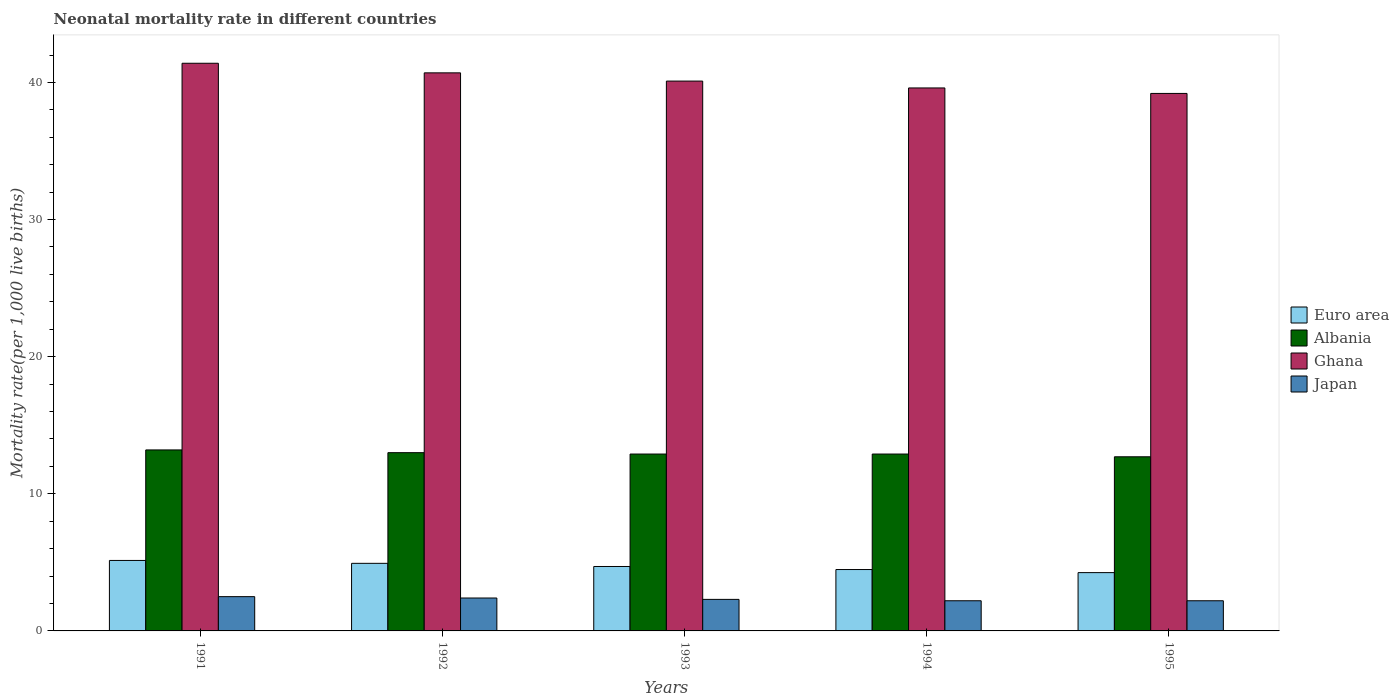How many different coloured bars are there?
Make the answer very short. 4. Are the number of bars per tick equal to the number of legend labels?
Your answer should be very brief. Yes. Are the number of bars on each tick of the X-axis equal?
Offer a terse response. Yes. How many bars are there on the 1st tick from the right?
Provide a short and direct response. 4. What is the neonatal mortality rate in Euro area in 1993?
Provide a short and direct response. 4.7. Across all years, what is the maximum neonatal mortality rate in Ghana?
Give a very brief answer. 41.4. Across all years, what is the minimum neonatal mortality rate in Euro area?
Your answer should be very brief. 4.25. In which year was the neonatal mortality rate in Albania maximum?
Give a very brief answer. 1991. In which year was the neonatal mortality rate in Albania minimum?
Your answer should be compact. 1995. What is the total neonatal mortality rate in Japan in the graph?
Your answer should be compact. 11.6. What is the difference between the neonatal mortality rate in Ghana in 1993 and that in 1994?
Offer a very short reply. 0.5. What is the difference between the neonatal mortality rate in Euro area in 1993 and the neonatal mortality rate in Albania in 1995?
Your answer should be very brief. -8. What is the average neonatal mortality rate in Japan per year?
Give a very brief answer. 2.32. In the year 1995, what is the difference between the neonatal mortality rate in Japan and neonatal mortality rate in Euro area?
Your answer should be very brief. -2.05. In how many years, is the neonatal mortality rate in Ghana greater than 6?
Keep it short and to the point. 5. What is the ratio of the neonatal mortality rate in Ghana in 1993 to that in 1994?
Give a very brief answer. 1.01. Is the difference between the neonatal mortality rate in Japan in 1991 and 1992 greater than the difference between the neonatal mortality rate in Euro area in 1991 and 1992?
Make the answer very short. No. What is the difference between the highest and the second highest neonatal mortality rate in Ghana?
Your response must be concise. 0.7. What is the difference between the highest and the lowest neonatal mortality rate in Euro area?
Ensure brevity in your answer.  0.89. Is the sum of the neonatal mortality rate in Albania in 1991 and 1994 greater than the maximum neonatal mortality rate in Japan across all years?
Provide a succinct answer. Yes. What does the 2nd bar from the left in 1994 represents?
Offer a terse response. Albania. How many bars are there?
Offer a terse response. 20. Are all the bars in the graph horizontal?
Keep it short and to the point. No. Are the values on the major ticks of Y-axis written in scientific E-notation?
Your answer should be compact. No. Does the graph contain any zero values?
Give a very brief answer. No. How many legend labels are there?
Ensure brevity in your answer.  4. How are the legend labels stacked?
Your answer should be very brief. Vertical. What is the title of the graph?
Provide a succinct answer. Neonatal mortality rate in different countries. What is the label or title of the X-axis?
Keep it short and to the point. Years. What is the label or title of the Y-axis?
Your answer should be very brief. Mortality rate(per 1,0 live births). What is the Mortality rate(per 1,000 live births) of Euro area in 1991?
Your answer should be compact. 5.14. What is the Mortality rate(per 1,000 live births) of Ghana in 1991?
Your response must be concise. 41.4. What is the Mortality rate(per 1,000 live births) of Japan in 1991?
Provide a succinct answer. 2.5. What is the Mortality rate(per 1,000 live births) of Euro area in 1992?
Provide a short and direct response. 4.93. What is the Mortality rate(per 1,000 live births) in Ghana in 1992?
Offer a terse response. 40.7. What is the Mortality rate(per 1,000 live births) of Euro area in 1993?
Make the answer very short. 4.7. What is the Mortality rate(per 1,000 live births) in Albania in 1993?
Make the answer very short. 12.9. What is the Mortality rate(per 1,000 live births) in Ghana in 1993?
Offer a terse response. 40.1. What is the Mortality rate(per 1,000 live births) of Euro area in 1994?
Give a very brief answer. 4.48. What is the Mortality rate(per 1,000 live births) in Albania in 1994?
Give a very brief answer. 12.9. What is the Mortality rate(per 1,000 live births) in Ghana in 1994?
Your response must be concise. 39.6. What is the Mortality rate(per 1,000 live births) of Japan in 1994?
Keep it short and to the point. 2.2. What is the Mortality rate(per 1,000 live births) of Euro area in 1995?
Keep it short and to the point. 4.25. What is the Mortality rate(per 1,000 live births) in Ghana in 1995?
Offer a terse response. 39.2. What is the Mortality rate(per 1,000 live births) in Japan in 1995?
Offer a terse response. 2.2. Across all years, what is the maximum Mortality rate(per 1,000 live births) of Euro area?
Offer a very short reply. 5.14. Across all years, what is the maximum Mortality rate(per 1,000 live births) in Ghana?
Ensure brevity in your answer.  41.4. Across all years, what is the maximum Mortality rate(per 1,000 live births) in Japan?
Your answer should be very brief. 2.5. Across all years, what is the minimum Mortality rate(per 1,000 live births) in Euro area?
Provide a short and direct response. 4.25. Across all years, what is the minimum Mortality rate(per 1,000 live births) of Ghana?
Ensure brevity in your answer.  39.2. Across all years, what is the minimum Mortality rate(per 1,000 live births) in Japan?
Offer a very short reply. 2.2. What is the total Mortality rate(per 1,000 live births) of Euro area in the graph?
Your response must be concise. 23.5. What is the total Mortality rate(per 1,000 live births) of Albania in the graph?
Make the answer very short. 64.7. What is the total Mortality rate(per 1,000 live births) of Ghana in the graph?
Give a very brief answer. 201. What is the total Mortality rate(per 1,000 live births) in Japan in the graph?
Offer a terse response. 11.6. What is the difference between the Mortality rate(per 1,000 live births) in Euro area in 1991 and that in 1992?
Your answer should be very brief. 0.21. What is the difference between the Mortality rate(per 1,000 live births) in Japan in 1991 and that in 1992?
Give a very brief answer. 0.1. What is the difference between the Mortality rate(per 1,000 live births) of Euro area in 1991 and that in 1993?
Your response must be concise. 0.44. What is the difference between the Mortality rate(per 1,000 live births) of Albania in 1991 and that in 1993?
Your answer should be compact. 0.3. What is the difference between the Mortality rate(per 1,000 live births) of Japan in 1991 and that in 1993?
Your response must be concise. 0.2. What is the difference between the Mortality rate(per 1,000 live births) of Euro area in 1991 and that in 1994?
Offer a very short reply. 0.66. What is the difference between the Mortality rate(per 1,000 live births) of Ghana in 1991 and that in 1994?
Offer a terse response. 1.8. What is the difference between the Mortality rate(per 1,000 live births) in Euro area in 1991 and that in 1995?
Provide a succinct answer. 0.89. What is the difference between the Mortality rate(per 1,000 live births) in Ghana in 1991 and that in 1995?
Your response must be concise. 2.2. What is the difference between the Mortality rate(per 1,000 live births) in Euro area in 1992 and that in 1993?
Your answer should be compact. 0.23. What is the difference between the Mortality rate(per 1,000 live births) of Ghana in 1992 and that in 1993?
Ensure brevity in your answer.  0.6. What is the difference between the Mortality rate(per 1,000 live births) of Euro area in 1992 and that in 1994?
Your answer should be very brief. 0.45. What is the difference between the Mortality rate(per 1,000 live births) of Euro area in 1992 and that in 1995?
Provide a succinct answer. 0.68. What is the difference between the Mortality rate(per 1,000 live births) of Albania in 1992 and that in 1995?
Offer a very short reply. 0.3. What is the difference between the Mortality rate(per 1,000 live births) of Euro area in 1993 and that in 1994?
Give a very brief answer. 0.22. What is the difference between the Mortality rate(per 1,000 live births) of Albania in 1993 and that in 1994?
Provide a succinct answer. 0. What is the difference between the Mortality rate(per 1,000 live births) of Ghana in 1993 and that in 1994?
Give a very brief answer. 0.5. What is the difference between the Mortality rate(per 1,000 live births) in Euro area in 1993 and that in 1995?
Provide a succinct answer. 0.45. What is the difference between the Mortality rate(per 1,000 live births) in Euro area in 1994 and that in 1995?
Provide a succinct answer. 0.22. What is the difference between the Mortality rate(per 1,000 live births) in Albania in 1994 and that in 1995?
Offer a very short reply. 0.2. What is the difference between the Mortality rate(per 1,000 live births) in Japan in 1994 and that in 1995?
Provide a succinct answer. 0. What is the difference between the Mortality rate(per 1,000 live births) in Euro area in 1991 and the Mortality rate(per 1,000 live births) in Albania in 1992?
Offer a very short reply. -7.86. What is the difference between the Mortality rate(per 1,000 live births) in Euro area in 1991 and the Mortality rate(per 1,000 live births) in Ghana in 1992?
Make the answer very short. -35.56. What is the difference between the Mortality rate(per 1,000 live births) in Euro area in 1991 and the Mortality rate(per 1,000 live births) in Japan in 1992?
Offer a very short reply. 2.74. What is the difference between the Mortality rate(per 1,000 live births) in Albania in 1991 and the Mortality rate(per 1,000 live births) in Ghana in 1992?
Provide a short and direct response. -27.5. What is the difference between the Mortality rate(per 1,000 live births) of Ghana in 1991 and the Mortality rate(per 1,000 live births) of Japan in 1992?
Give a very brief answer. 39. What is the difference between the Mortality rate(per 1,000 live births) in Euro area in 1991 and the Mortality rate(per 1,000 live births) in Albania in 1993?
Your response must be concise. -7.76. What is the difference between the Mortality rate(per 1,000 live births) of Euro area in 1991 and the Mortality rate(per 1,000 live births) of Ghana in 1993?
Keep it short and to the point. -34.96. What is the difference between the Mortality rate(per 1,000 live births) of Euro area in 1991 and the Mortality rate(per 1,000 live births) of Japan in 1993?
Ensure brevity in your answer.  2.84. What is the difference between the Mortality rate(per 1,000 live births) in Albania in 1991 and the Mortality rate(per 1,000 live births) in Ghana in 1993?
Ensure brevity in your answer.  -26.9. What is the difference between the Mortality rate(per 1,000 live births) of Ghana in 1991 and the Mortality rate(per 1,000 live births) of Japan in 1993?
Keep it short and to the point. 39.1. What is the difference between the Mortality rate(per 1,000 live births) of Euro area in 1991 and the Mortality rate(per 1,000 live births) of Albania in 1994?
Offer a terse response. -7.76. What is the difference between the Mortality rate(per 1,000 live births) in Euro area in 1991 and the Mortality rate(per 1,000 live births) in Ghana in 1994?
Your answer should be compact. -34.46. What is the difference between the Mortality rate(per 1,000 live births) of Euro area in 1991 and the Mortality rate(per 1,000 live births) of Japan in 1994?
Make the answer very short. 2.94. What is the difference between the Mortality rate(per 1,000 live births) of Albania in 1991 and the Mortality rate(per 1,000 live births) of Ghana in 1994?
Provide a succinct answer. -26.4. What is the difference between the Mortality rate(per 1,000 live births) of Ghana in 1991 and the Mortality rate(per 1,000 live births) of Japan in 1994?
Provide a succinct answer. 39.2. What is the difference between the Mortality rate(per 1,000 live births) of Euro area in 1991 and the Mortality rate(per 1,000 live births) of Albania in 1995?
Offer a very short reply. -7.56. What is the difference between the Mortality rate(per 1,000 live births) of Euro area in 1991 and the Mortality rate(per 1,000 live births) of Ghana in 1995?
Give a very brief answer. -34.06. What is the difference between the Mortality rate(per 1,000 live births) of Euro area in 1991 and the Mortality rate(per 1,000 live births) of Japan in 1995?
Keep it short and to the point. 2.94. What is the difference between the Mortality rate(per 1,000 live births) in Albania in 1991 and the Mortality rate(per 1,000 live births) in Ghana in 1995?
Your answer should be compact. -26. What is the difference between the Mortality rate(per 1,000 live births) of Albania in 1991 and the Mortality rate(per 1,000 live births) of Japan in 1995?
Offer a terse response. 11. What is the difference between the Mortality rate(per 1,000 live births) in Ghana in 1991 and the Mortality rate(per 1,000 live births) in Japan in 1995?
Keep it short and to the point. 39.2. What is the difference between the Mortality rate(per 1,000 live births) in Euro area in 1992 and the Mortality rate(per 1,000 live births) in Albania in 1993?
Your answer should be compact. -7.97. What is the difference between the Mortality rate(per 1,000 live births) in Euro area in 1992 and the Mortality rate(per 1,000 live births) in Ghana in 1993?
Provide a succinct answer. -35.17. What is the difference between the Mortality rate(per 1,000 live births) in Euro area in 1992 and the Mortality rate(per 1,000 live births) in Japan in 1993?
Make the answer very short. 2.63. What is the difference between the Mortality rate(per 1,000 live births) in Albania in 1992 and the Mortality rate(per 1,000 live births) in Ghana in 1993?
Keep it short and to the point. -27.1. What is the difference between the Mortality rate(per 1,000 live births) in Ghana in 1992 and the Mortality rate(per 1,000 live births) in Japan in 1993?
Offer a terse response. 38.4. What is the difference between the Mortality rate(per 1,000 live births) of Euro area in 1992 and the Mortality rate(per 1,000 live births) of Albania in 1994?
Offer a very short reply. -7.97. What is the difference between the Mortality rate(per 1,000 live births) of Euro area in 1992 and the Mortality rate(per 1,000 live births) of Ghana in 1994?
Keep it short and to the point. -34.67. What is the difference between the Mortality rate(per 1,000 live births) in Euro area in 1992 and the Mortality rate(per 1,000 live births) in Japan in 1994?
Your answer should be very brief. 2.73. What is the difference between the Mortality rate(per 1,000 live births) in Albania in 1992 and the Mortality rate(per 1,000 live births) in Ghana in 1994?
Offer a very short reply. -26.6. What is the difference between the Mortality rate(per 1,000 live births) in Ghana in 1992 and the Mortality rate(per 1,000 live births) in Japan in 1994?
Ensure brevity in your answer.  38.5. What is the difference between the Mortality rate(per 1,000 live births) in Euro area in 1992 and the Mortality rate(per 1,000 live births) in Albania in 1995?
Provide a succinct answer. -7.77. What is the difference between the Mortality rate(per 1,000 live births) in Euro area in 1992 and the Mortality rate(per 1,000 live births) in Ghana in 1995?
Keep it short and to the point. -34.27. What is the difference between the Mortality rate(per 1,000 live births) in Euro area in 1992 and the Mortality rate(per 1,000 live births) in Japan in 1995?
Ensure brevity in your answer.  2.73. What is the difference between the Mortality rate(per 1,000 live births) in Albania in 1992 and the Mortality rate(per 1,000 live births) in Ghana in 1995?
Offer a very short reply. -26.2. What is the difference between the Mortality rate(per 1,000 live births) in Ghana in 1992 and the Mortality rate(per 1,000 live births) in Japan in 1995?
Keep it short and to the point. 38.5. What is the difference between the Mortality rate(per 1,000 live births) of Euro area in 1993 and the Mortality rate(per 1,000 live births) of Albania in 1994?
Offer a terse response. -8.2. What is the difference between the Mortality rate(per 1,000 live births) in Euro area in 1993 and the Mortality rate(per 1,000 live births) in Ghana in 1994?
Offer a terse response. -34.9. What is the difference between the Mortality rate(per 1,000 live births) in Euro area in 1993 and the Mortality rate(per 1,000 live births) in Japan in 1994?
Your response must be concise. 2.5. What is the difference between the Mortality rate(per 1,000 live births) in Albania in 1993 and the Mortality rate(per 1,000 live births) in Ghana in 1994?
Offer a terse response. -26.7. What is the difference between the Mortality rate(per 1,000 live births) of Ghana in 1993 and the Mortality rate(per 1,000 live births) of Japan in 1994?
Ensure brevity in your answer.  37.9. What is the difference between the Mortality rate(per 1,000 live births) of Euro area in 1993 and the Mortality rate(per 1,000 live births) of Albania in 1995?
Offer a very short reply. -8. What is the difference between the Mortality rate(per 1,000 live births) in Euro area in 1993 and the Mortality rate(per 1,000 live births) in Ghana in 1995?
Keep it short and to the point. -34.5. What is the difference between the Mortality rate(per 1,000 live births) in Euro area in 1993 and the Mortality rate(per 1,000 live births) in Japan in 1995?
Keep it short and to the point. 2.5. What is the difference between the Mortality rate(per 1,000 live births) in Albania in 1993 and the Mortality rate(per 1,000 live births) in Ghana in 1995?
Ensure brevity in your answer.  -26.3. What is the difference between the Mortality rate(per 1,000 live births) in Ghana in 1993 and the Mortality rate(per 1,000 live births) in Japan in 1995?
Your answer should be compact. 37.9. What is the difference between the Mortality rate(per 1,000 live births) in Euro area in 1994 and the Mortality rate(per 1,000 live births) in Albania in 1995?
Ensure brevity in your answer.  -8.22. What is the difference between the Mortality rate(per 1,000 live births) in Euro area in 1994 and the Mortality rate(per 1,000 live births) in Ghana in 1995?
Keep it short and to the point. -34.72. What is the difference between the Mortality rate(per 1,000 live births) in Euro area in 1994 and the Mortality rate(per 1,000 live births) in Japan in 1995?
Your answer should be very brief. 2.28. What is the difference between the Mortality rate(per 1,000 live births) of Albania in 1994 and the Mortality rate(per 1,000 live births) of Ghana in 1995?
Make the answer very short. -26.3. What is the difference between the Mortality rate(per 1,000 live births) of Ghana in 1994 and the Mortality rate(per 1,000 live births) of Japan in 1995?
Make the answer very short. 37.4. What is the average Mortality rate(per 1,000 live births) of Euro area per year?
Ensure brevity in your answer.  4.7. What is the average Mortality rate(per 1,000 live births) in Albania per year?
Provide a succinct answer. 12.94. What is the average Mortality rate(per 1,000 live births) in Ghana per year?
Give a very brief answer. 40.2. What is the average Mortality rate(per 1,000 live births) of Japan per year?
Offer a terse response. 2.32. In the year 1991, what is the difference between the Mortality rate(per 1,000 live births) of Euro area and Mortality rate(per 1,000 live births) of Albania?
Ensure brevity in your answer.  -8.06. In the year 1991, what is the difference between the Mortality rate(per 1,000 live births) in Euro area and Mortality rate(per 1,000 live births) in Ghana?
Keep it short and to the point. -36.26. In the year 1991, what is the difference between the Mortality rate(per 1,000 live births) of Euro area and Mortality rate(per 1,000 live births) of Japan?
Offer a very short reply. 2.64. In the year 1991, what is the difference between the Mortality rate(per 1,000 live births) of Albania and Mortality rate(per 1,000 live births) of Ghana?
Your answer should be very brief. -28.2. In the year 1991, what is the difference between the Mortality rate(per 1,000 live births) of Albania and Mortality rate(per 1,000 live births) of Japan?
Offer a terse response. 10.7. In the year 1991, what is the difference between the Mortality rate(per 1,000 live births) in Ghana and Mortality rate(per 1,000 live births) in Japan?
Keep it short and to the point. 38.9. In the year 1992, what is the difference between the Mortality rate(per 1,000 live births) in Euro area and Mortality rate(per 1,000 live births) in Albania?
Give a very brief answer. -8.07. In the year 1992, what is the difference between the Mortality rate(per 1,000 live births) of Euro area and Mortality rate(per 1,000 live births) of Ghana?
Make the answer very short. -35.77. In the year 1992, what is the difference between the Mortality rate(per 1,000 live births) in Euro area and Mortality rate(per 1,000 live births) in Japan?
Ensure brevity in your answer.  2.53. In the year 1992, what is the difference between the Mortality rate(per 1,000 live births) of Albania and Mortality rate(per 1,000 live births) of Ghana?
Keep it short and to the point. -27.7. In the year 1992, what is the difference between the Mortality rate(per 1,000 live births) in Ghana and Mortality rate(per 1,000 live births) in Japan?
Offer a terse response. 38.3. In the year 1993, what is the difference between the Mortality rate(per 1,000 live births) in Euro area and Mortality rate(per 1,000 live births) in Albania?
Your answer should be very brief. -8.2. In the year 1993, what is the difference between the Mortality rate(per 1,000 live births) in Euro area and Mortality rate(per 1,000 live births) in Ghana?
Give a very brief answer. -35.4. In the year 1993, what is the difference between the Mortality rate(per 1,000 live births) in Euro area and Mortality rate(per 1,000 live births) in Japan?
Your answer should be compact. 2.4. In the year 1993, what is the difference between the Mortality rate(per 1,000 live births) in Albania and Mortality rate(per 1,000 live births) in Ghana?
Provide a short and direct response. -27.2. In the year 1993, what is the difference between the Mortality rate(per 1,000 live births) of Albania and Mortality rate(per 1,000 live births) of Japan?
Your response must be concise. 10.6. In the year 1993, what is the difference between the Mortality rate(per 1,000 live births) of Ghana and Mortality rate(per 1,000 live births) of Japan?
Your answer should be very brief. 37.8. In the year 1994, what is the difference between the Mortality rate(per 1,000 live births) of Euro area and Mortality rate(per 1,000 live births) of Albania?
Offer a terse response. -8.42. In the year 1994, what is the difference between the Mortality rate(per 1,000 live births) of Euro area and Mortality rate(per 1,000 live births) of Ghana?
Keep it short and to the point. -35.12. In the year 1994, what is the difference between the Mortality rate(per 1,000 live births) of Euro area and Mortality rate(per 1,000 live births) of Japan?
Give a very brief answer. 2.28. In the year 1994, what is the difference between the Mortality rate(per 1,000 live births) in Albania and Mortality rate(per 1,000 live births) in Ghana?
Keep it short and to the point. -26.7. In the year 1994, what is the difference between the Mortality rate(per 1,000 live births) in Albania and Mortality rate(per 1,000 live births) in Japan?
Ensure brevity in your answer.  10.7. In the year 1994, what is the difference between the Mortality rate(per 1,000 live births) in Ghana and Mortality rate(per 1,000 live births) in Japan?
Offer a very short reply. 37.4. In the year 1995, what is the difference between the Mortality rate(per 1,000 live births) of Euro area and Mortality rate(per 1,000 live births) of Albania?
Offer a terse response. -8.45. In the year 1995, what is the difference between the Mortality rate(per 1,000 live births) in Euro area and Mortality rate(per 1,000 live births) in Ghana?
Offer a very short reply. -34.95. In the year 1995, what is the difference between the Mortality rate(per 1,000 live births) in Euro area and Mortality rate(per 1,000 live births) in Japan?
Provide a succinct answer. 2.05. In the year 1995, what is the difference between the Mortality rate(per 1,000 live births) of Albania and Mortality rate(per 1,000 live births) of Ghana?
Provide a succinct answer. -26.5. In the year 1995, what is the difference between the Mortality rate(per 1,000 live births) of Albania and Mortality rate(per 1,000 live births) of Japan?
Keep it short and to the point. 10.5. What is the ratio of the Mortality rate(per 1,000 live births) in Euro area in 1991 to that in 1992?
Give a very brief answer. 1.04. What is the ratio of the Mortality rate(per 1,000 live births) in Albania in 1991 to that in 1992?
Your answer should be very brief. 1.02. What is the ratio of the Mortality rate(per 1,000 live births) in Ghana in 1991 to that in 1992?
Provide a short and direct response. 1.02. What is the ratio of the Mortality rate(per 1,000 live births) of Japan in 1991 to that in 1992?
Offer a terse response. 1.04. What is the ratio of the Mortality rate(per 1,000 live births) in Euro area in 1991 to that in 1993?
Give a very brief answer. 1.09. What is the ratio of the Mortality rate(per 1,000 live births) in Albania in 1991 to that in 1993?
Offer a very short reply. 1.02. What is the ratio of the Mortality rate(per 1,000 live births) in Ghana in 1991 to that in 1993?
Make the answer very short. 1.03. What is the ratio of the Mortality rate(per 1,000 live births) of Japan in 1991 to that in 1993?
Provide a succinct answer. 1.09. What is the ratio of the Mortality rate(per 1,000 live births) in Euro area in 1991 to that in 1994?
Keep it short and to the point. 1.15. What is the ratio of the Mortality rate(per 1,000 live births) in Albania in 1991 to that in 1994?
Provide a short and direct response. 1.02. What is the ratio of the Mortality rate(per 1,000 live births) in Ghana in 1991 to that in 1994?
Provide a succinct answer. 1.05. What is the ratio of the Mortality rate(per 1,000 live births) of Japan in 1991 to that in 1994?
Provide a succinct answer. 1.14. What is the ratio of the Mortality rate(per 1,000 live births) in Euro area in 1991 to that in 1995?
Give a very brief answer. 1.21. What is the ratio of the Mortality rate(per 1,000 live births) in Albania in 1991 to that in 1995?
Give a very brief answer. 1.04. What is the ratio of the Mortality rate(per 1,000 live births) of Ghana in 1991 to that in 1995?
Keep it short and to the point. 1.06. What is the ratio of the Mortality rate(per 1,000 live births) in Japan in 1991 to that in 1995?
Offer a terse response. 1.14. What is the ratio of the Mortality rate(per 1,000 live births) in Euro area in 1992 to that in 1993?
Provide a short and direct response. 1.05. What is the ratio of the Mortality rate(per 1,000 live births) in Albania in 1992 to that in 1993?
Your answer should be compact. 1.01. What is the ratio of the Mortality rate(per 1,000 live births) in Ghana in 1992 to that in 1993?
Keep it short and to the point. 1.01. What is the ratio of the Mortality rate(per 1,000 live births) in Japan in 1992 to that in 1993?
Your answer should be very brief. 1.04. What is the ratio of the Mortality rate(per 1,000 live births) in Euro area in 1992 to that in 1994?
Make the answer very short. 1.1. What is the ratio of the Mortality rate(per 1,000 live births) of Ghana in 1992 to that in 1994?
Provide a short and direct response. 1.03. What is the ratio of the Mortality rate(per 1,000 live births) of Euro area in 1992 to that in 1995?
Your answer should be very brief. 1.16. What is the ratio of the Mortality rate(per 1,000 live births) of Albania in 1992 to that in 1995?
Your response must be concise. 1.02. What is the ratio of the Mortality rate(per 1,000 live births) in Ghana in 1992 to that in 1995?
Give a very brief answer. 1.04. What is the ratio of the Mortality rate(per 1,000 live births) in Japan in 1992 to that in 1995?
Give a very brief answer. 1.09. What is the ratio of the Mortality rate(per 1,000 live births) of Euro area in 1993 to that in 1994?
Your answer should be very brief. 1.05. What is the ratio of the Mortality rate(per 1,000 live births) of Albania in 1993 to that in 1994?
Ensure brevity in your answer.  1. What is the ratio of the Mortality rate(per 1,000 live births) in Ghana in 1993 to that in 1994?
Your answer should be compact. 1.01. What is the ratio of the Mortality rate(per 1,000 live births) in Japan in 1993 to that in 1994?
Provide a short and direct response. 1.05. What is the ratio of the Mortality rate(per 1,000 live births) of Euro area in 1993 to that in 1995?
Provide a short and direct response. 1.11. What is the ratio of the Mortality rate(per 1,000 live births) of Albania in 1993 to that in 1995?
Keep it short and to the point. 1.02. What is the ratio of the Mortality rate(per 1,000 live births) of Ghana in 1993 to that in 1995?
Give a very brief answer. 1.02. What is the ratio of the Mortality rate(per 1,000 live births) of Japan in 1993 to that in 1995?
Offer a terse response. 1.05. What is the ratio of the Mortality rate(per 1,000 live births) in Euro area in 1994 to that in 1995?
Your response must be concise. 1.05. What is the ratio of the Mortality rate(per 1,000 live births) in Albania in 1994 to that in 1995?
Offer a very short reply. 1.02. What is the ratio of the Mortality rate(per 1,000 live births) in Ghana in 1994 to that in 1995?
Keep it short and to the point. 1.01. What is the ratio of the Mortality rate(per 1,000 live births) of Japan in 1994 to that in 1995?
Your response must be concise. 1. What is the difference between the highest and the second highest Mortality rate(per 1,000 live births) in Euro area?
Ensure brevity in your answer.  0.21. What is the difference between the highest and the second highest Mortality rate(per 1,000 live births) of Ghana?
Keep it short and to the point. 0.7. What is the difference between the highest and the second highest Mortality rate(per 1,000 live births) in Japan?
Ensure brevity in your answer.  0.1. What is the difference between the highest and the lowest Mortality rate(per 1,000 live births) in Euro area?
Provide a short and direct response. 0.89. 